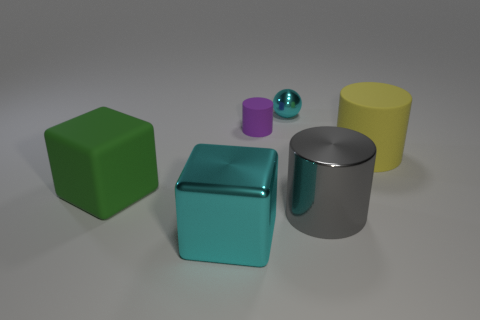Subtract all large metal cylinders. How many cylinders are left? 2 Subtract 3 cylinders. How many cylinders are left? 0 Subtract all cyan cubes. How many cubes are left? 1 Add 1 big rubber things. How many objects exist? 7 Subtract all cubes. How many objects are left? 4 Subtract all blue cylinders. How many green blocks are left? 1 Subtract 1 gray cylinders. How many objects are left? 5 Subtract all red blocks. Subtract all brown balls. How many blocks are left? 2 Subtract all tiny metal balls. Subtract all tiny purple objects. How many objects are left? 4 Add 4 large green matte objects. How many large green matte objects are left? 5 